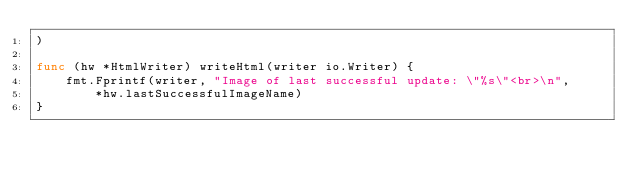Convert code to text. <code><loc_0><loc_0><loc_500><loc_500><_Go_>)

func (hw *HtmlWriter) writeHtml(writer io.Writer) {
	fmt.Fprintf(writer, "Image of last successful update: \"%s\"<br>\n",
		*hw.lastSuccessfulImageName)
}
</code> 